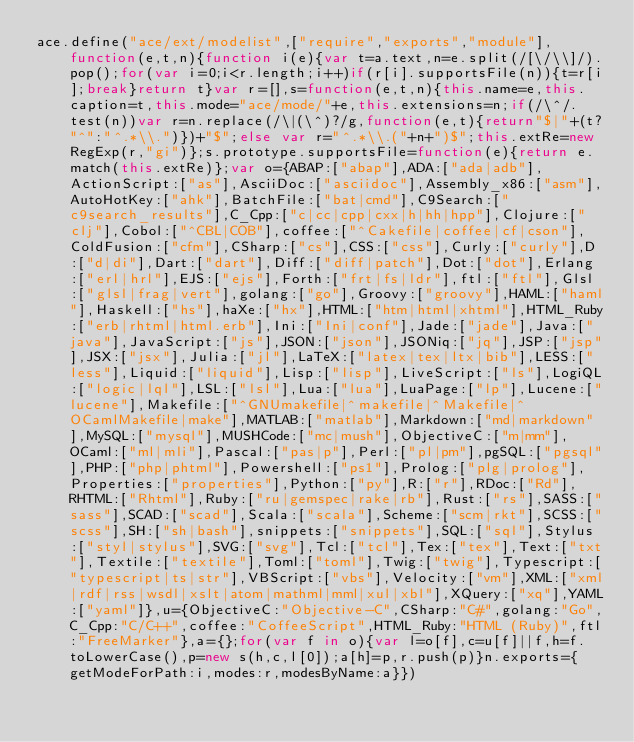Convert code to text. <code><loc_0><loc_0><loc_500><loc_500><_JavaScript_>ace.define("ace/ext/modelist",["require","exports","module"],function(e,t,n){function i(e){var t=a.text,n=e.split(/[\/\\]/).pop();for(var i=0;i<r.length;i++)if(r[i].supportsFile(n)){t=r[i];break}return t}var r=[],s=function(e,t,n){this.name=e,this.caption=t,this.mode="ace/mode/"+e,this.extensions=n;if(/\^/.test(n))var r=n.replace(/\|(\^)?/g,function(e,t){return"$|"+(t?"^":"^.*\\.")})+"$";else var r="^.*\\.("+n+")$";this.extRe=new RegExp(r,"gi")};s.prototype.supportsFile=function(e){return e.match(this.extRe)};var o={ABAP:["abap"],ADA:["ada|adb"],ActionScript:["as"],AsciiDoc:["asciidoc"],Assembly_x86:["asm"],AutoHotKey:["ahk"],BatchFile:["bat|cmd"],C9Search:["c9search_results"],C_Cpp:["c|cc|cpp|cxx|h|hh|hpp"],Clojure:["clj"],Cobol:["^CBL|COB"],coffee:["^Cakefile|coffee|cf|cson"],ColdFusion:["cfm"],CSharp:["cs"],CSS:["css"],Curly:["curly"],D:["d|di"],Dart:["dart"],Diff:["diff|patch"],Dot:["dot"],Erlang:["erl|hrl"],EJS:["ejs"],Forth:["frt|fs|ldr"],ftl:["ftl"],Glsl:["glsl|frag|vert"],golang:["go"],Groovy:["groovy"],HAML:["haml"],Haskell:["hs"],haXe:["hx"],HTML:["htm|html|xhtml"],HTML_Ruby:["erb|rhtml|html.erb"],Ini:["Ini|conf"],Jade:["jade"],Java:["java"],JavaScript:["js"],JSON:["json"],JSONiq:["jq"],JSP:["jsp"],JSX:["jsx"],Julia:["jl"],LaTeX:["latex|tex|ltx|bib"],LESS:["less"],Liquid:["liquid"],Lisp:["lisp"],LiveScript:["ls"],LogiQL:["logic|lql"],LSL:["lsl"],Lua:["lua"],LuaPage:["lp"],Lucene:["lucene"],Makefile:["^GNUmakefile|^makefile|^Makefile|^OCamlMakefile|make"],MATLAB:["matlab"],Markdown:["md|markdown"],MySQL:["mysql"],MUSHCode:["mc|mush"],ObjectiveC:["m|mm"],OCaml:["ml|mli"],Pascal:["pas|p"],Perl:["pl|pm"],pgSQL:["pgsql"],PHP:["php|phtml"],Powershell:["ps1"],Prolog:["plg|prolog"],Properties:["properties"],Python:["py"],R:["r"],RDoc:["Rd"],RHTML:["Rhtml"],Ruby:["ru|gemspec|rake|rb"],Rust:["rs"],SASS:["sass"],SCAD:["scad"],Scala:["scala"],Scheme:["scm|rkt"],SCSS:["scss"],SH:["sh|bash"],snippets:["snippets"],SQL:["sql"],Stylus:["styl|stylus"],SVG:["svg"],Tcl:["tcl"],Tex:["tex"],Text:["txt"],Textile:["textile"],Toml:["toml"],Twig:["twig"],Typescript:["typescript|ts|str"],VBScript:["vbs"],Velocity:["vm"],XML:["xml|rdf|rss|wsdl|xslt|atom|mathml|mml|xul|xbl"],XQuery:["xq"],YAML:["yaml"]},u={ObjectiveC:"Objective-C",CSharp:"C#",golang:"Go",C_Cpp:"C/C++",coffee:"CoffeeScript",HTML_Ruby:"HTML (Ruby)",ftl:"FreeMarker"},a={};for(var f in o){var l=o[f],c=u[f]||f,h=f.toLowerCase(),p=new s(h,c,l[0]);a[h]=p,r.push(p)}n.exports={getModeForPath:i,modes:r,modesByName:a}})</code> 